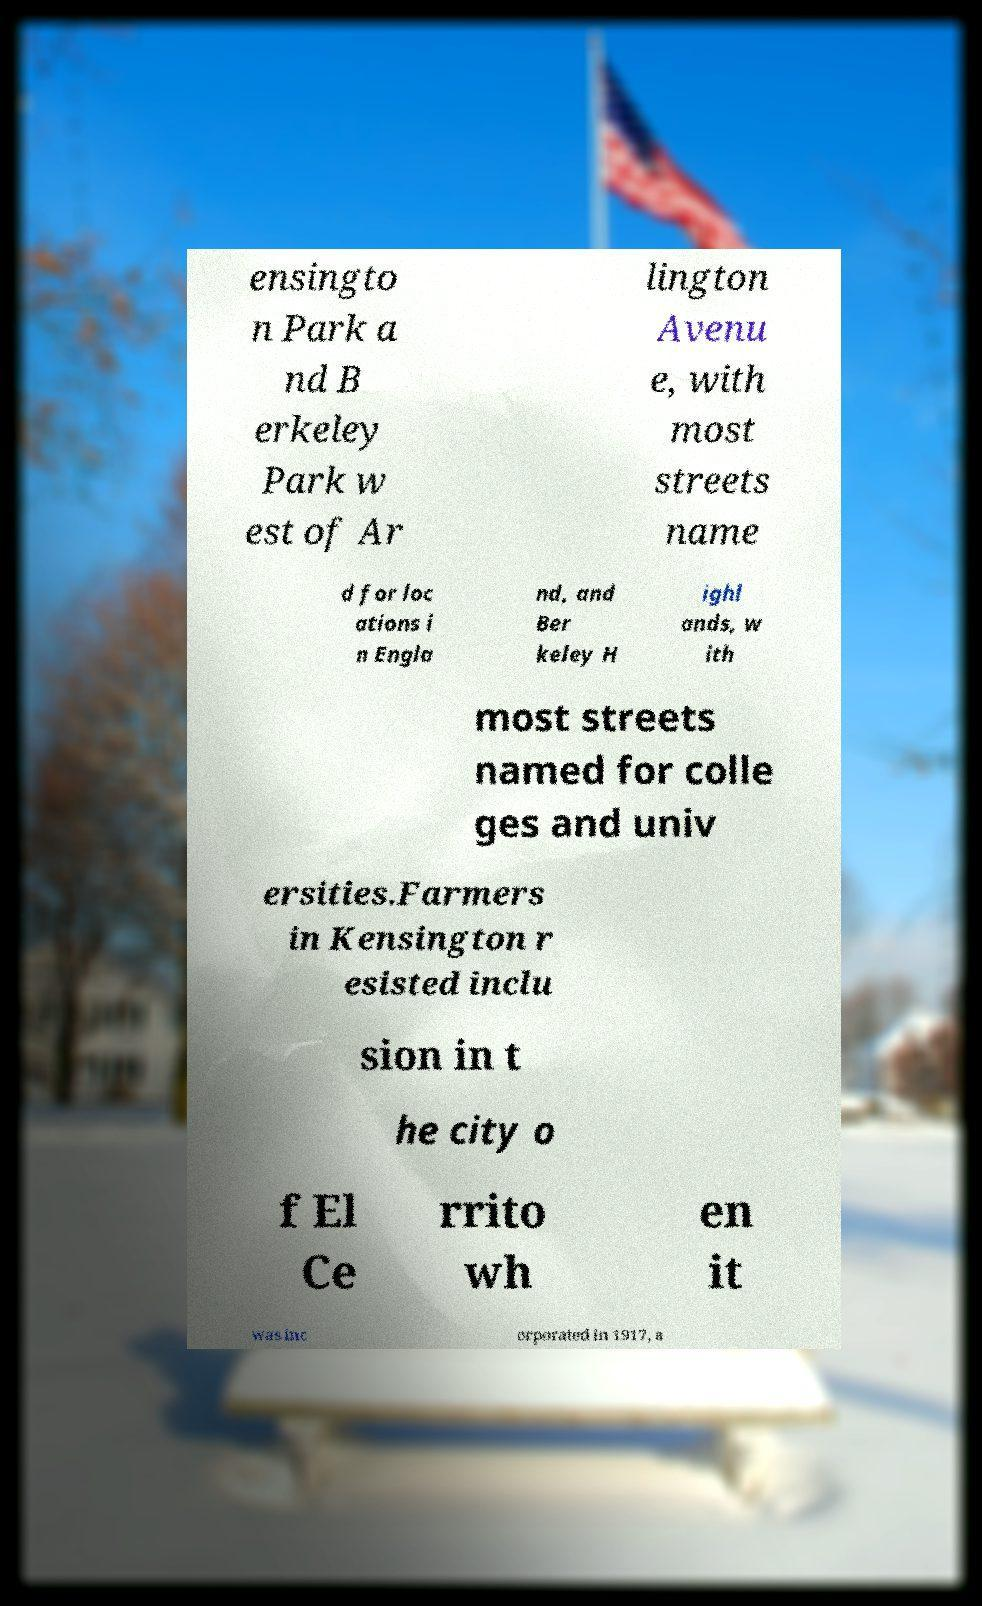Could you assist in decoding the text presented in this image and type it out clearly? ensingto n Park a nd B erkeley Park w est of Ar lington Avenu e, with most streets name d for loc ations i n Engla nd, and Ber keley H ighl ands, w ith most streets named for colle ges and univ ersities.Farmers in Kensington r esisted inclu sion in t he city o f El Ce rrito wh en it was inc orporated in 1917, a 